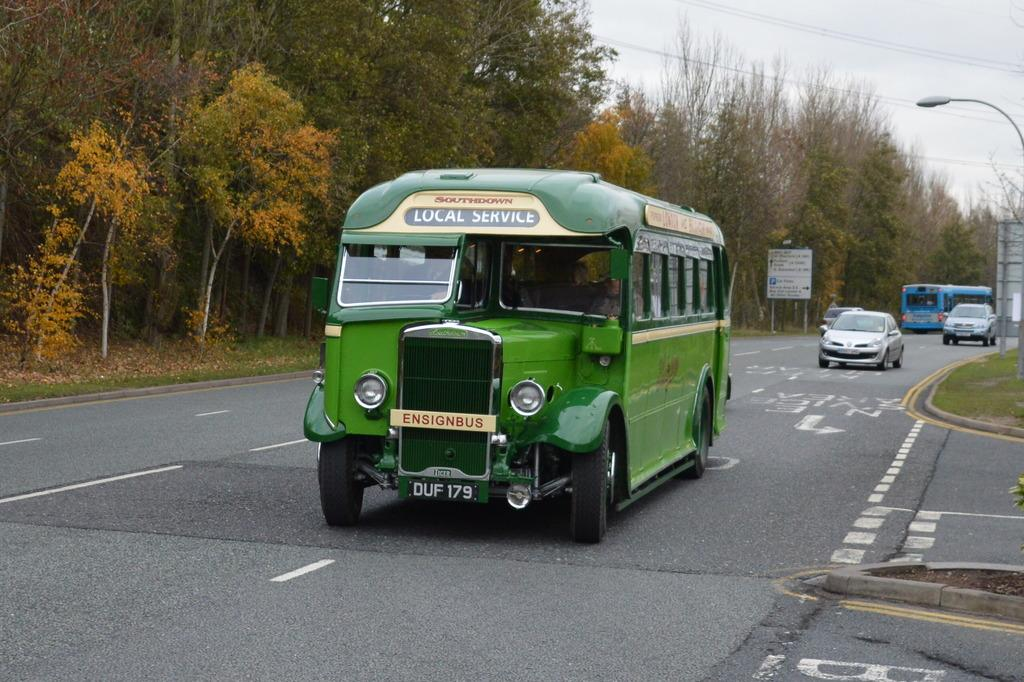What can be seen on the road in the image? There are vehicles on the road in the image. What type of natural elements are visible in the image? There are trees visible in the image. What objects are present in the image that are not vehicles or trees? There are boards in the image. What is the purpose of the street light on the right side of the image? The street light on the right side of the image provides illumination for the road and surrounding area. What is visible in the background of the image? The sky is visible in the background of the image. Who is the owner of the cup in the image? There is no cup present in the image. What activity are the vehicles engaged in within the image? The provided facts do not specify any specific activity the vehicles are engaged in; they are simply on the road. 